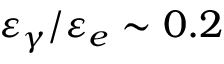<formula> <loc_0><loc_0><loc_500><loc_500>\varepsilon _ { \gamma } / \varepsilon _ { e } \sim 0 . 2</formula> 